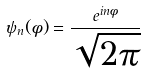Convert formula to latex. <formula><loc_0><loc_0><loc_500><loc_500>\psi _ { n } ( \phi ) = { \frac { e ^ { i n \phi } } { \sqrt { 2 \pi } } }</formula> 